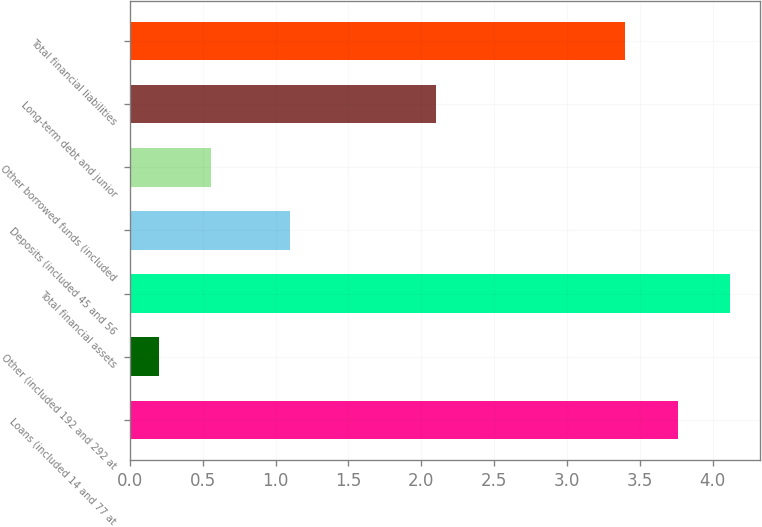Convert chart to OTSL. <chart><loc_0><loc_0><loc_500><loc_500><bar_chart><fcel>Loans (included 14 and 77 at<fcel>Other (included 192 and 292 at<fcel>Total financial assets<fcel>Deposits (included 45 and 56<fcel>Other borrowed funds (included<fcel>Long-term debt and junior<fcel>Total financial liabilities<nl><fcel>3.76<fcel>0.2<fcel>4.12<fcel>1.1<fcel>0.56<fcel>2.1<fcel>3.4<nl></chart> 